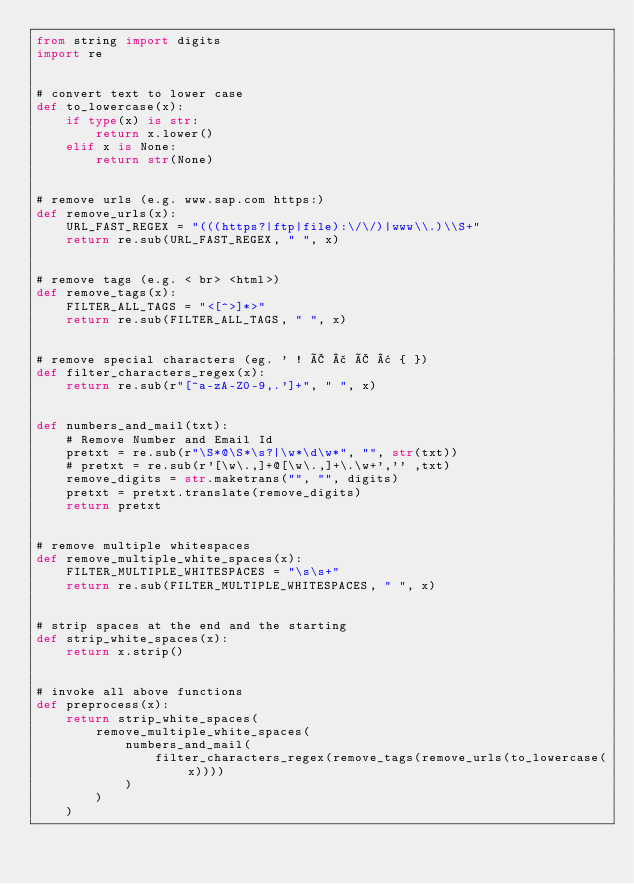Convert code to text. <code><loc_0><loc_0><loc_500><loc_500><_Python_>from string import digits
import re


# convert text to lower case
def to_lowercase(x):
    if type(x) is str:
        return x.lower()
    elif x is None:
        return str(None)


# remove urls (e.g. www.sap.com https:)
def remove_urls(x):
    URL_FAST_REGEX = "(((https?|ftp|file):\/\/)|www\\.)\\S+"
    return re.sub(URL_FAST_REGEX, " ", x)


# remove tags (e.g. < br> <html>)
def remove_tags(x):
    FILTER_ALL_TAGS = "<[^>]*>"
    return re.sub(FILTER_ALL_TAGS, " ", x)


# remove special characters (eg. ' ! Ã £ Ã ¢ { })
def filter_characters_regex(x):
    return re.sub(r"[^a-zA-Z0-9,.']+", " ", x)


def numbers_and_mail(txt):
    # Remove Number and Email Id
    pretxt = re.sub(r"\S*@\S*\s?|\w*\d\w*", "", str(txt))
    # pretxt = re.sub(r'[\w\.,]+@[\w\.,]+\.\w+','' ,txt)
    remove_digits = str.maketrans("", "", digits)
    pretxt = pretxt.translate(remove_digits)
    return pretxt


# remove multiple whitespaces
def remove_multiple_white_spaces(x):
    FILTER_MULTIPLE_WHITESPACES = "\s\s+"
    return re.sub(FILTER_MULTIPLE_WHITESPACES, " ", x)


# strip spaces at the end and the starting
def strip_white_spaces(x):
    return x.strip()


# invoke all above functions
def preprocess(x):
    return strip_white_spaces(
        remove_multiple_white_spaces(
            numbers_and_mail(
                filter_characters_regex(remove_tags(remove_urls(to_lowercase(x))))
            )
        )
    )
</code> 